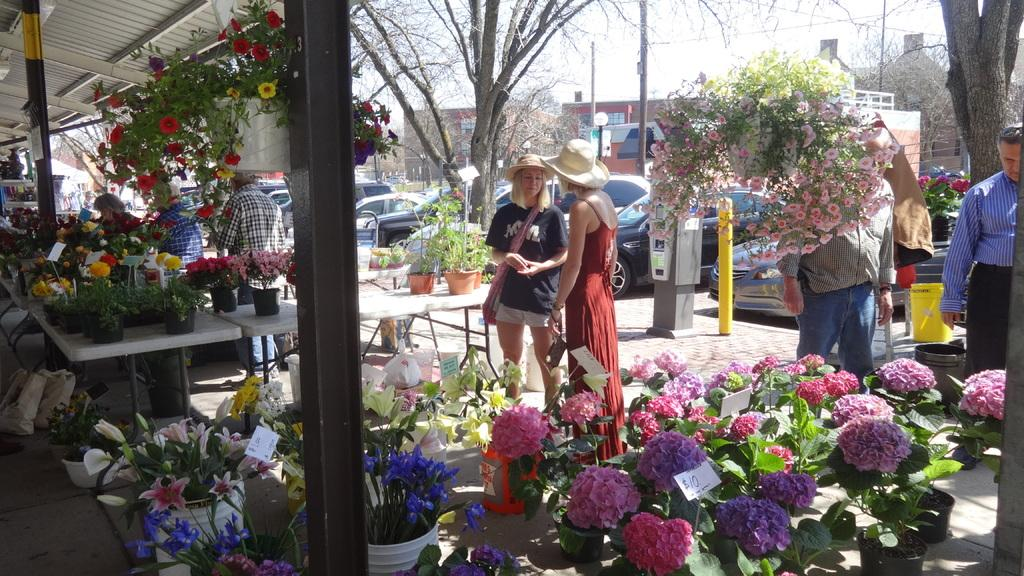What type of objects can be seen in the image that are related to plants? There are colorful flower pots in the image. Can you describe the people in the image? There are people standing in the image. What other natural elements are present in the image? There are trees in the image. What can be seen in the background of the image? There is a building in the background of the image. What is visible in the sky in the image? The sky is visible in the image. What type of food is being prepared in the box in the image? There is no box or food preparation visible in the image. What part of the brain can be seen in the image? There is no brain present in the image. 